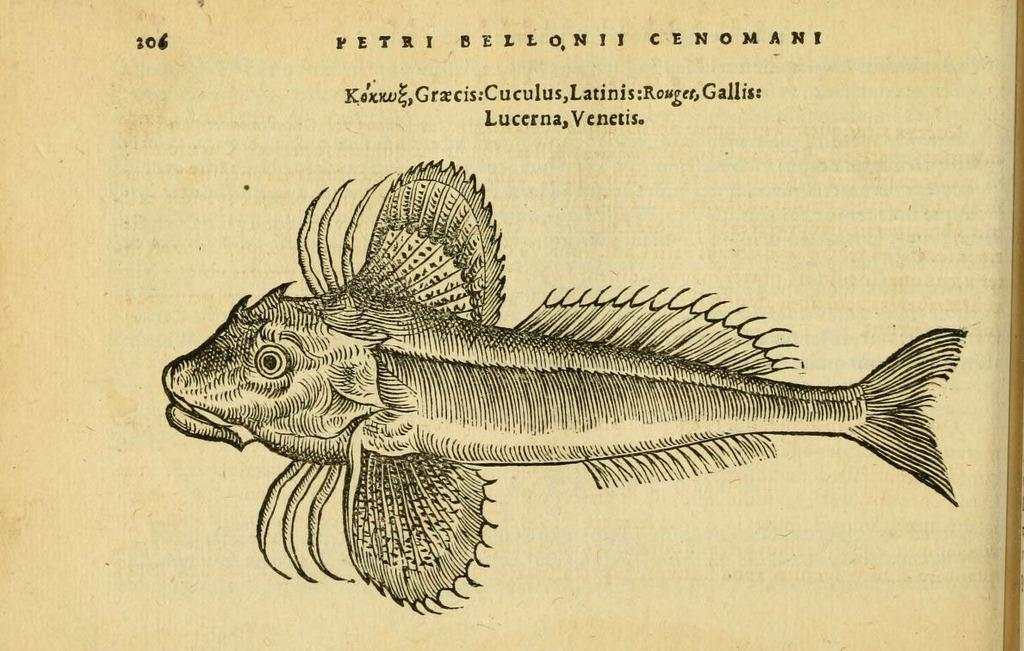What is present on the paper in the image? The paper contains a picture of a fish. Is there any text on the paper? Yes, there is text on the paper. What type of brush is used to paint the chin of the fish in the image? There is no brush or chin of a fish present in the image; it only contains a picture of a fish. 